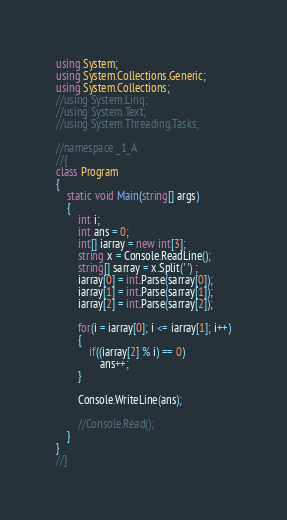<code> <loc_0><loc_0><loc_500><loc_500><_C#_>using System;
using System.Collections.Generic;
using System.Collections;
//using System.Linq;
//using System.Text;
//using System.Threading.Tasks;

//namespace _1_A
//{
class Program
{
    static void Main(string[] args)
    {
        int i;
        int ans = 0;
        int[] iarray = new int[3];
        string x = Console.ReadLine();
        string[] sarray = x.Split(' ') ;
        iarray[0] = int.Parse(sarray[0]);
        iarray[1] = int.Parse(sarray[1]);
        iarray[2] = int.Parse(sarray[2]);

        for(i = iarray[0]; i <= iarray[1]; i++)
        {
            if((iarray[2] % i) == 0)
                ans++;
        }

        Console.WriteLine(ans);

        //Console.Read();
    }
}
//}</code> 